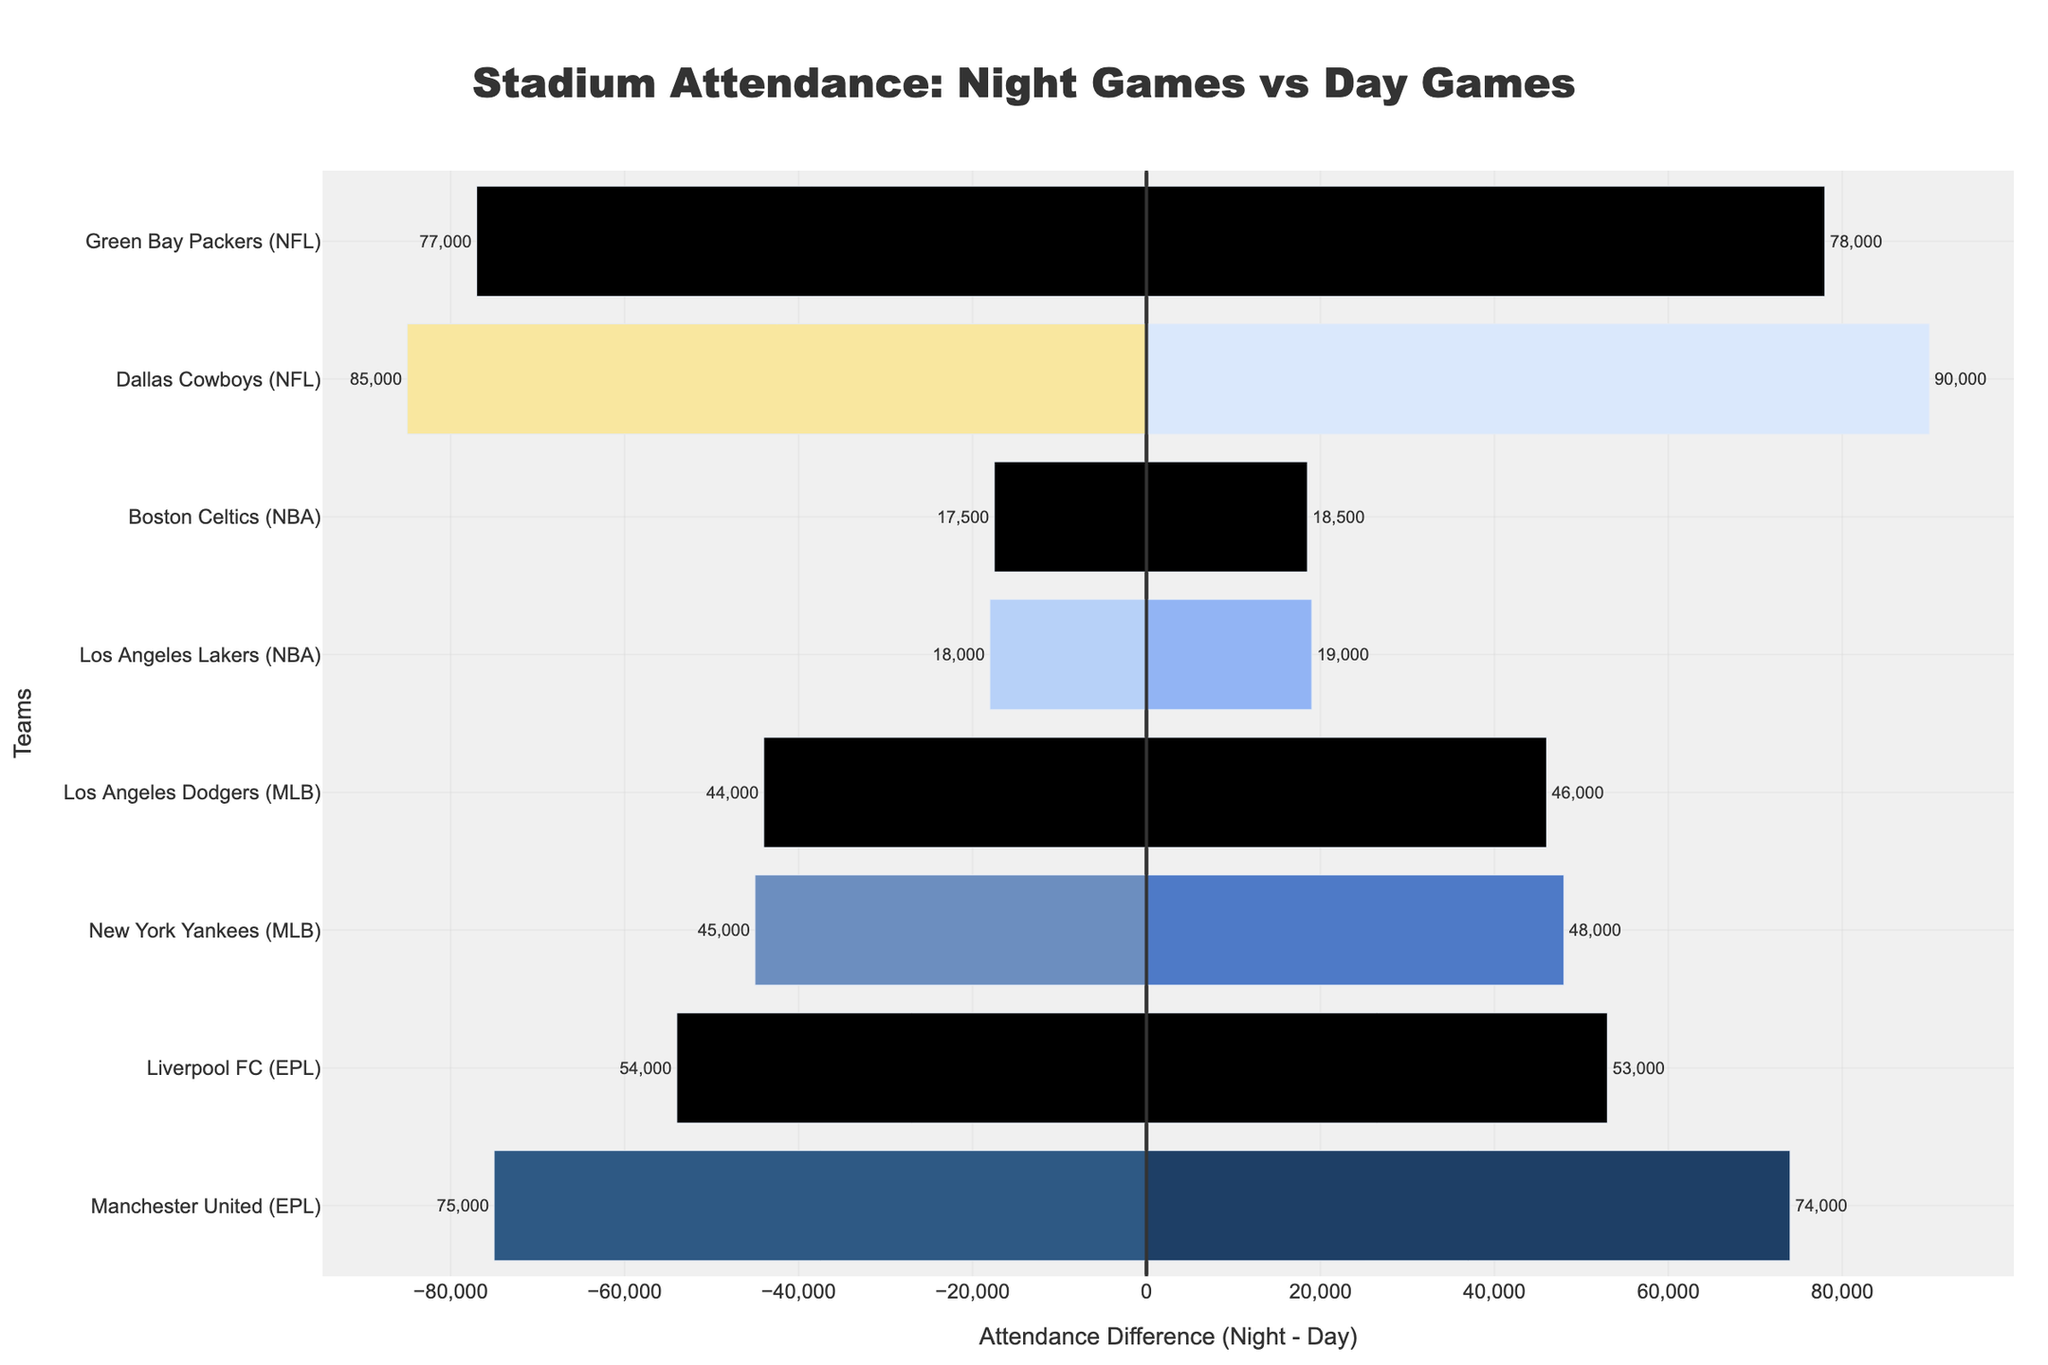Which NFL team had a greater difference in attendance between night and day games? The Dallas Cowboys had an attendance difference of 50,000 (90,000 - 85,000), while the Green Bay Packers had a difference of only 1,000 (78,000 - 77,000). Thus, Dallas Cowboys had a greater difference.
Answer: Dallas Cowboys Which team in the EPL had a negative difference in attendance between night and day games? Manchester United had a negative difference, with 74,000 at night and 75,000 during the day, resulting in a difference of -1,000. Liverpool FC had a difference of -1,000 (53,000 - 54,000).
Answer: Both What is the total attendance for the New York Yankees during night and day games combined? The New York Yankees had an attendance of 48,000 for night games and 45,000 for day games. Adding them together gives us 48,000 + 45,000 = 93,000.
Answer: 93,000 Which team has the smallest attendance difference in the NBA, and what is the difference? The Los Angeles Lakers have a difference of 1,000 (19,000 - 18,000), while the Boston Celtics have a difference of 1,000 (18,500 - 17,500). Both teams have the same smallest attendance difference in the NBA.
Answer: Both, 1,000 Between night and day games, for which league do most teams have higher attendance for night games than day games? Most NFL, NBA, and MLB teams show higher attendance during night games compared to day games. EPL teams show higher attendance during day games. Thus, checking, NFL, NBA, and MLB.
Answer: NFL, NBA, MLB What is the average attendance for night games across all teams? Add up the attendance for night games for all teams: 90,000 + 78,000 + 19,000 + 18,500 + 48,000 + 46,000 + 74,000 + 53,000 = 426,500. Divide that by the total number of teams (8): 426,500 / 8 = 53,312.5.
Answer: 53,312.5 Which team's bar is tallest in the positive direction, indicating the highest night game attendance? The bar for Dallas Cowboys reaches 90,000, which is the highest night game attendance shown on the chart.
Answer: Dallas Cowboys If we ranked teams by the absolute difference in attendance between night and day games, which team would be last? Sorting by smallest absolute differences: Green Bay Packers and Manchester United both have the smallest differences of 1,000.
Answer: Green Bay Packers, Manchester United What visual attribute indicates that the Green Bay Packers have nearly equal attendance during night and day games? The length of the Green Bay Packers bars is almost equal, and the slight positive difference indicates similar attendance figures for both night and day games. Notice how close the bar lengths are.
Answer: Nearly equal bar lengths 